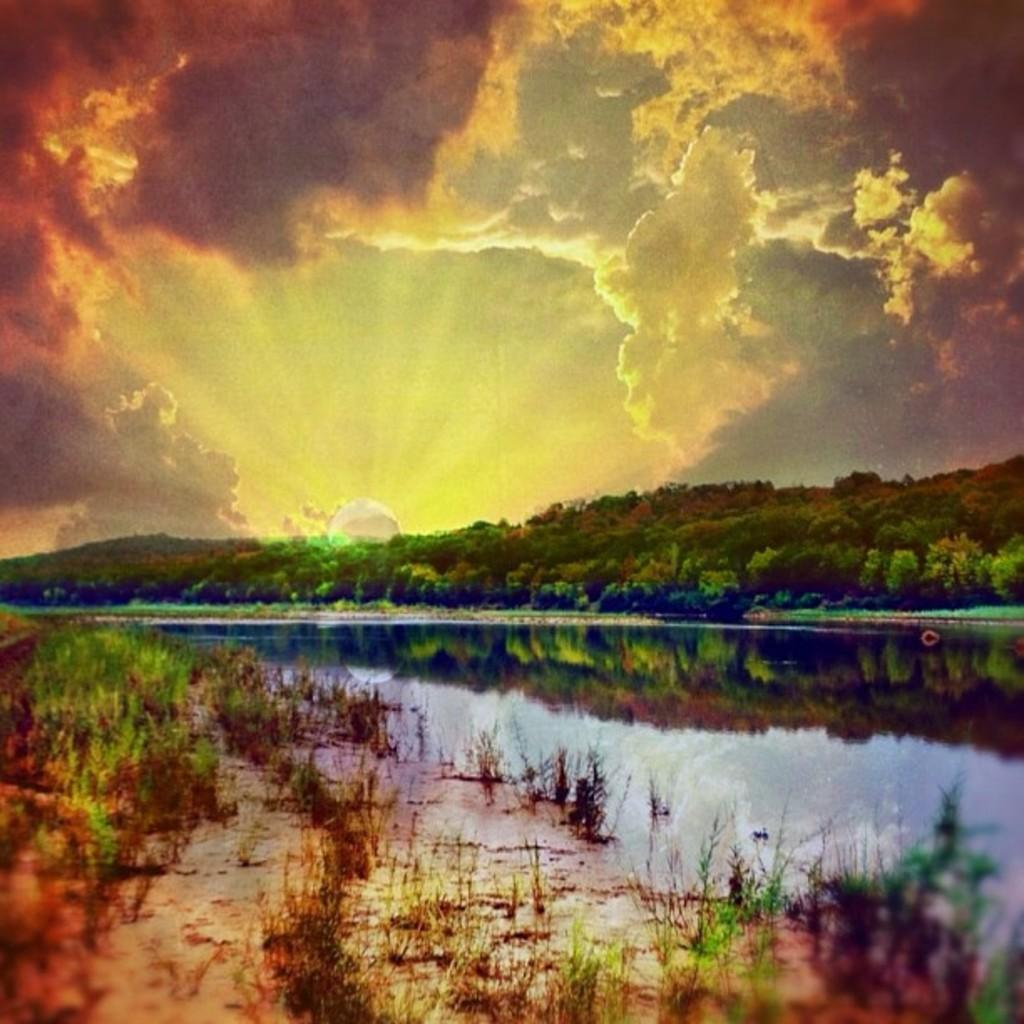What type of natural feature is present in the image? There is a river in the image. What is the primary substance visible in the image? There is water in the image. What type of vegetation can be seen in the image? There are plants and trees in the image. What is visible at the top of the image? The sky is visible at the top of the image. What can be observed in the sky? There are clouds in the sky. What type of force is being applied to the plate in the image? There is no plate present in the image, so no force is being applied to it. What is the wax used for in the image? There is no wax present in the image, so it is not being used for any purpose. 